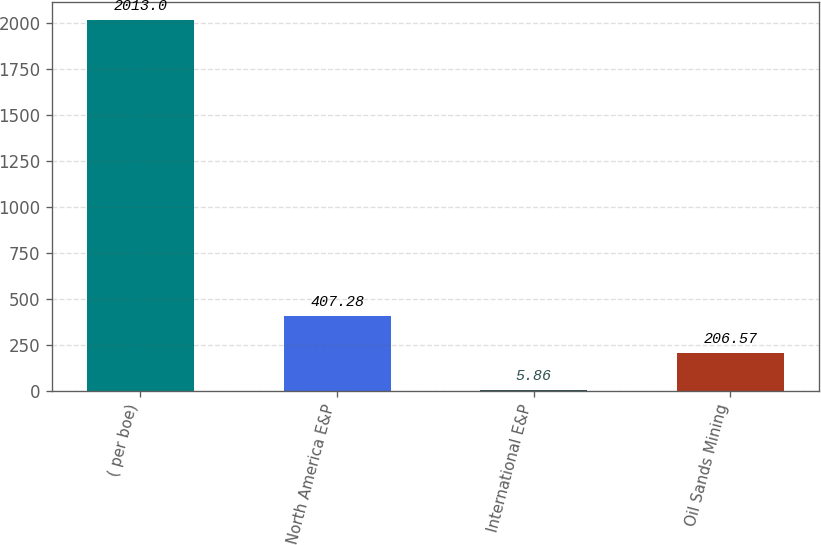Convert chart to OTSL. <chart><loc_0><loc_0><loc_500><loc_500><bar_chart><fcel>( per boe)<fcel>North America E&P<fcel>International E&P<fcel>Oil Sands Mining<nl><fcel>2013<fcel>407.28<fcel>5.86<fcel>206.57<nl></chart> 